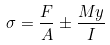<formula> <loc_0><loc_0><loc_500><loc_500>\sigma = \frac { F } { A } \pm \frac { M y } { I }</formula> 